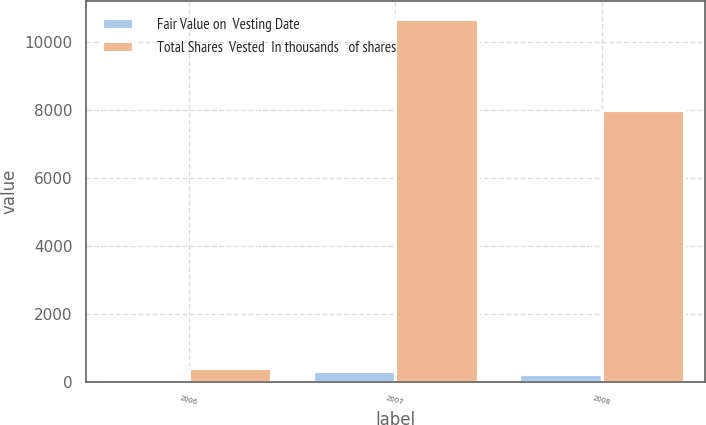<chart> <loc_0><loc_0><loc_500><loc_500><stacked_bar_chart><ecel><fcel>2006<fcel>2007<fcel>2008<nl><fcel>Fair Value on  Vesting Date<fcel>12<fcel>305<fcel>224<nl><fcel>Total Shares  Vested  In thousands   of shares<fcel>408<fcel>10686<fcel>8018<nl></chart> 